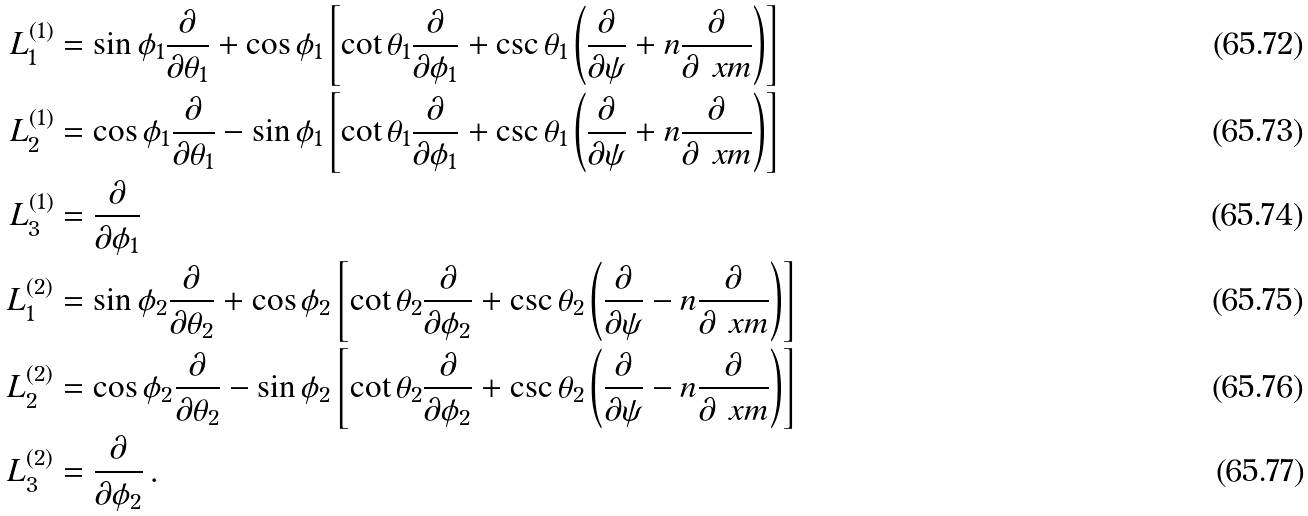Convert formula to latex. <formula><loc_0><loc_0><loc_500><loc_500>L ^ { ( 1 ) } _ { 1 } & = \sin \phi _ { 1 } \frac { \partial } { \partial \theta _ { 1 } } + \cos \phi _ { 1 } \left [ \cot \theta _ { 1 } \frac { \partial } { \partial \phi _ { 1 } } + \csc \theta _ { 1 } \left ( \frac { \partial } { \partial \psi } + n \frac { \partial } { \partial \ x m } \right ) \right ] \\ L ^ { ( 1 ) } _ { 2 } & = \cos \phi _ { 1 } \frac { \partial } { \partial \theta _ { 1 } } - \sin \phi _ { 1 } \left [ \cot \theta _ { 1 } \frac { \partial } { \partial \phi _ { 1 } } + \csc \theta _ { 1 } \left ( \frac { \partial } { \partial \psi } + n \frac { \partial } { \partial \ x m } \right ) \right ] \\ L ^ { ( 1 ) } _ { 3 } & = \frac { \partial } { \partial \phi _ { 1 } } \\ L ^ { ( 2 ) } _ { 1 } & = \sin \phi _ { 2 } \frac { \partial } { \partial \theta _ { 2 } } + \cos \phi _ { 2 } \left [ \cot \theta _ { 2 } \frac { \partial } { \partial \phi _ { 2 } } + \csc \theta _ { 2 } \left ( \frac { \partial } { \partial \psi } - n \frac { \partial } { \partial \ x m } \right ) \right ] \\ L ^ { ( 2 ) } _ { 2 } & = \cos \phi _ { 2 } \frac { \partial } { \partial \theta _ { 2 } } - \sin \phi _ { 2 } \left [ \cot \theta _ { 2 } \frac { \partial } { \partial \phi _ { 2 } } + \csc \theta _ { 2 } \left ( \frac { \partial } { \partial \psi } - n \frac { \partial } { \partial \ x m } \right ) \right ] \\ L ^ { ( 2 ) } _ { 3 } & = \frac { \partial } { \partial \phi _ { 2 } } \, .</formula> 